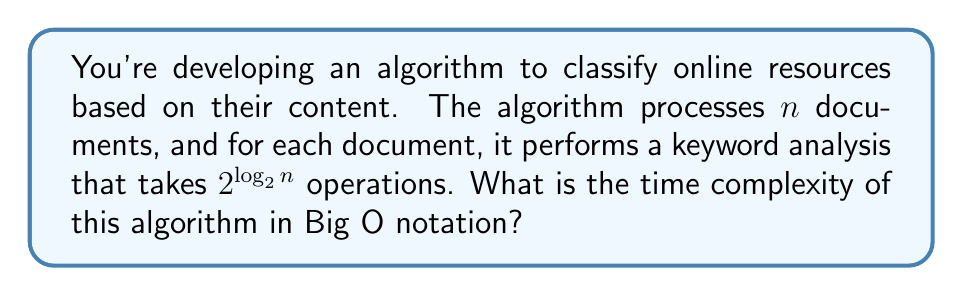Show me your answer to this math problem. Let's approach this step-by-step:

1) First, we need to understand what $2^{\log_2 n}$ means:
   - $\log_2 n$ is the logarithm of $n$ base 2
   - We're raising 2 to the power of this logarithm

2) There's a fundamental property of logarithms that we can use here:
   
   $$2^{\log_2 n} = n$$

   This is because $\log_2$ and $2^x$ are inverse functions.

3) So, for each document, the algorithm performs $n$ operations.

4) Since this is done for each of the $n$ documents, the total number of operations is:

   $$n \cdot n = n^2$$

5) In Big O notation, we express this as $O(n^2)$.

6) We always use the simplest form in Big O notation, so even if there were lower-order terms or constant factors, we would still express this as $O(n^2)$.
Answer: $O(n^2)$ 